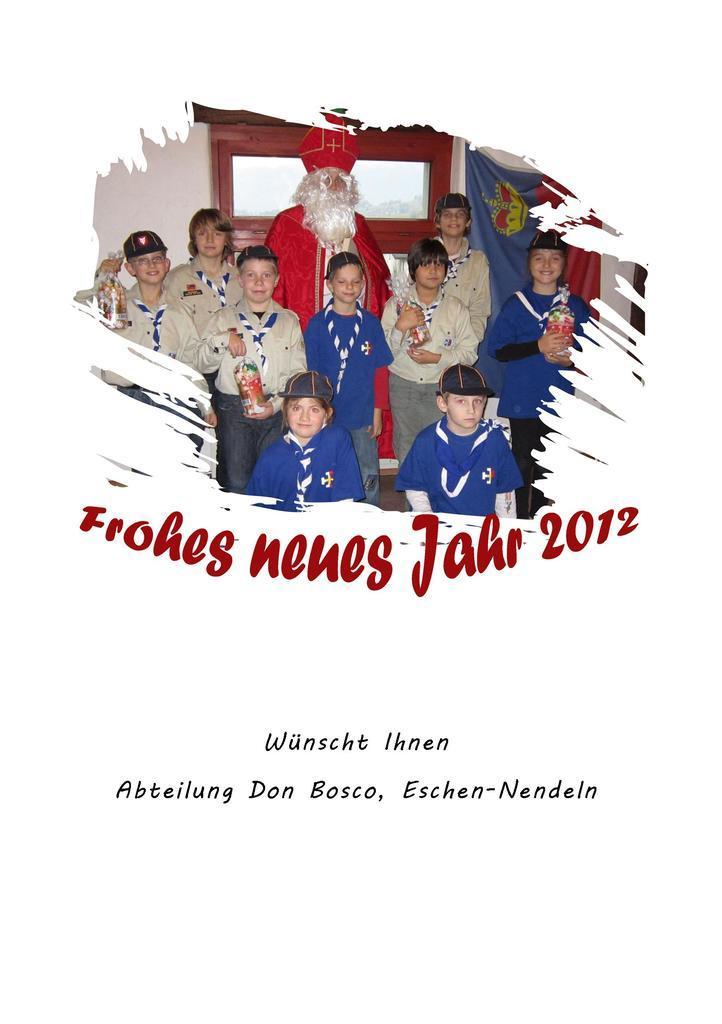In one or two sentences, can you explain what this image depicts? In the image we can see a poster, in the poster few people are standing and holding something in their hands. Behind them there is wall, on the wall there is a flag. 